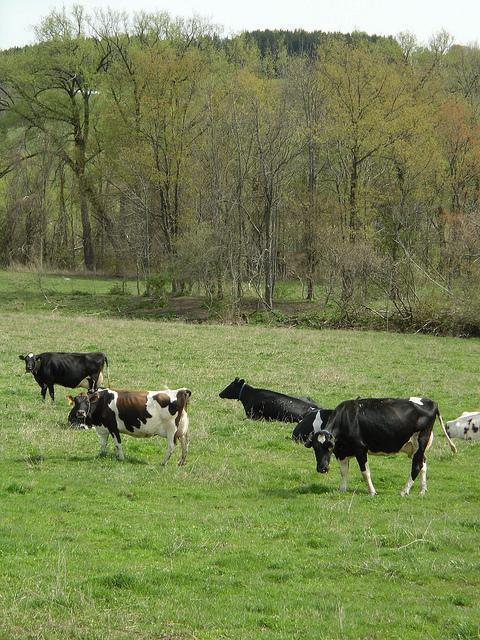What color is the strange cow just ahead to the left?
Choose the right answer from the provided options to respond to the question.
Options: Brown, white, black, gray. Brown. 